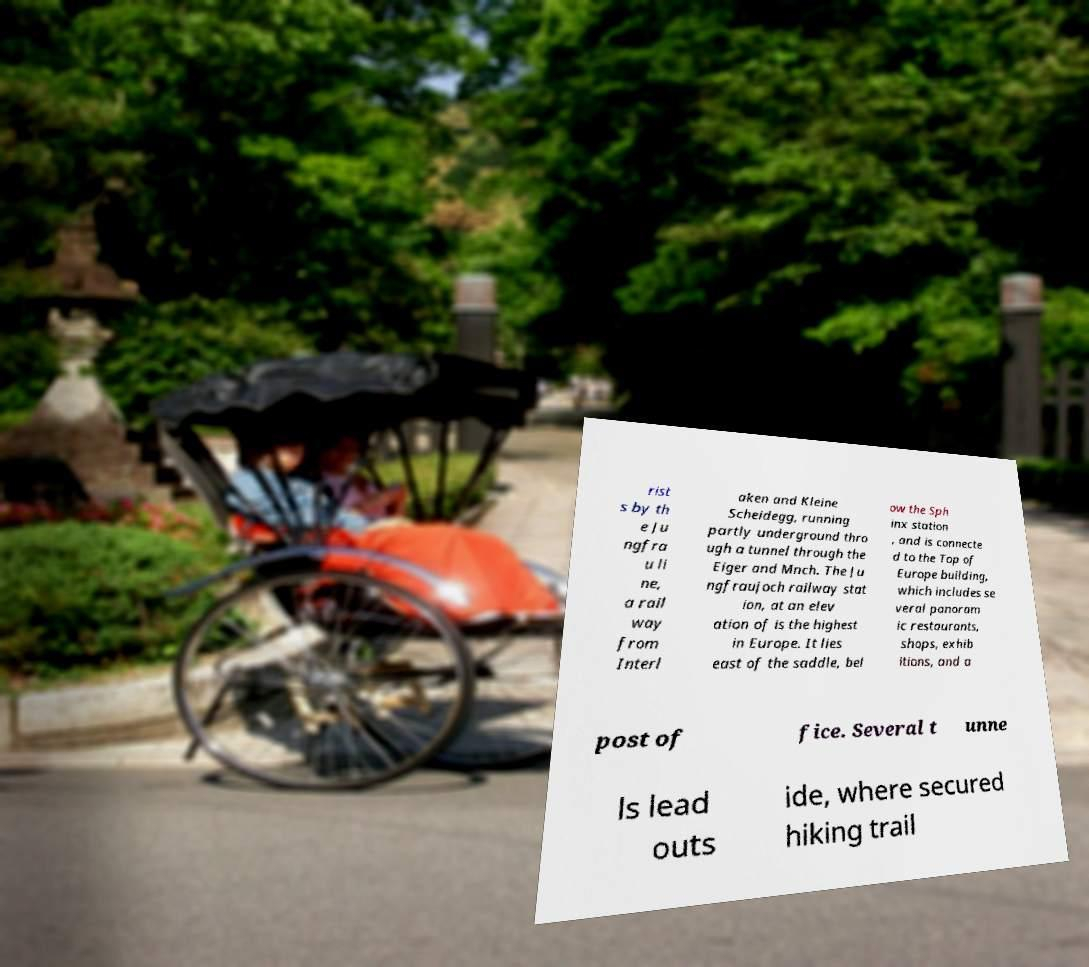For documentation purposes, I need the text within this image transcribed. Could you provide that? rist s by th e Ju ngfra u li ne, a rail way from Interl aken and Kleine Scheidegg, running partly underground thro ugh a tunnel through the Eiger and Mnch. The Ju ngfraujoch railway stat ion, at an elev ation of is the highest in Europe. It lies east of the saddle, bel ow the Sph inx station , and is connecte d to the Top of Europe building, which includes se veral panoram ic restaurants, shops, exhib itions, and a post of fice. Several t unne ls lead outs ide, where secured hiking trail 